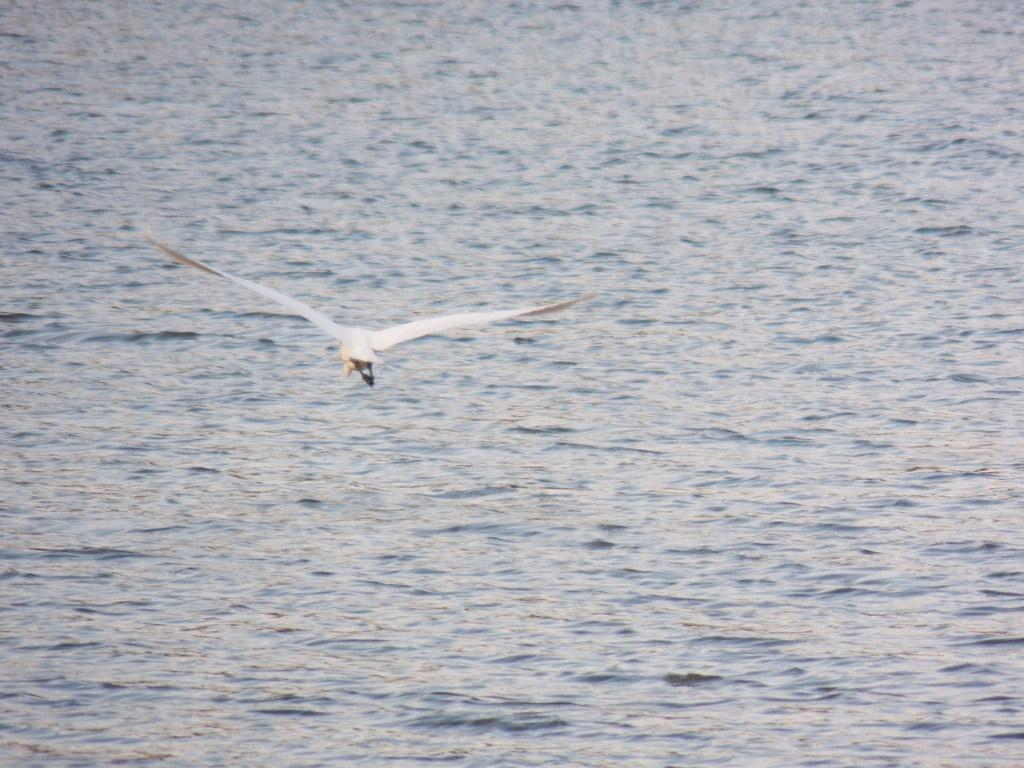What type of animal can be seen in the image? There is a bird in the image. What can be seen in the background of the image? There is water visible in the background of the image. What type of meat is the bird eating in the image? There is no meat present in the image; the bird is not shown eating anything. 